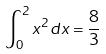<formula> <loc_0><loc_0><loc_500><loc_500>\int _ { 0 } ^ { 2 } x ^ { 2 } d x = \frac { 8 } { 3 }</formula> 